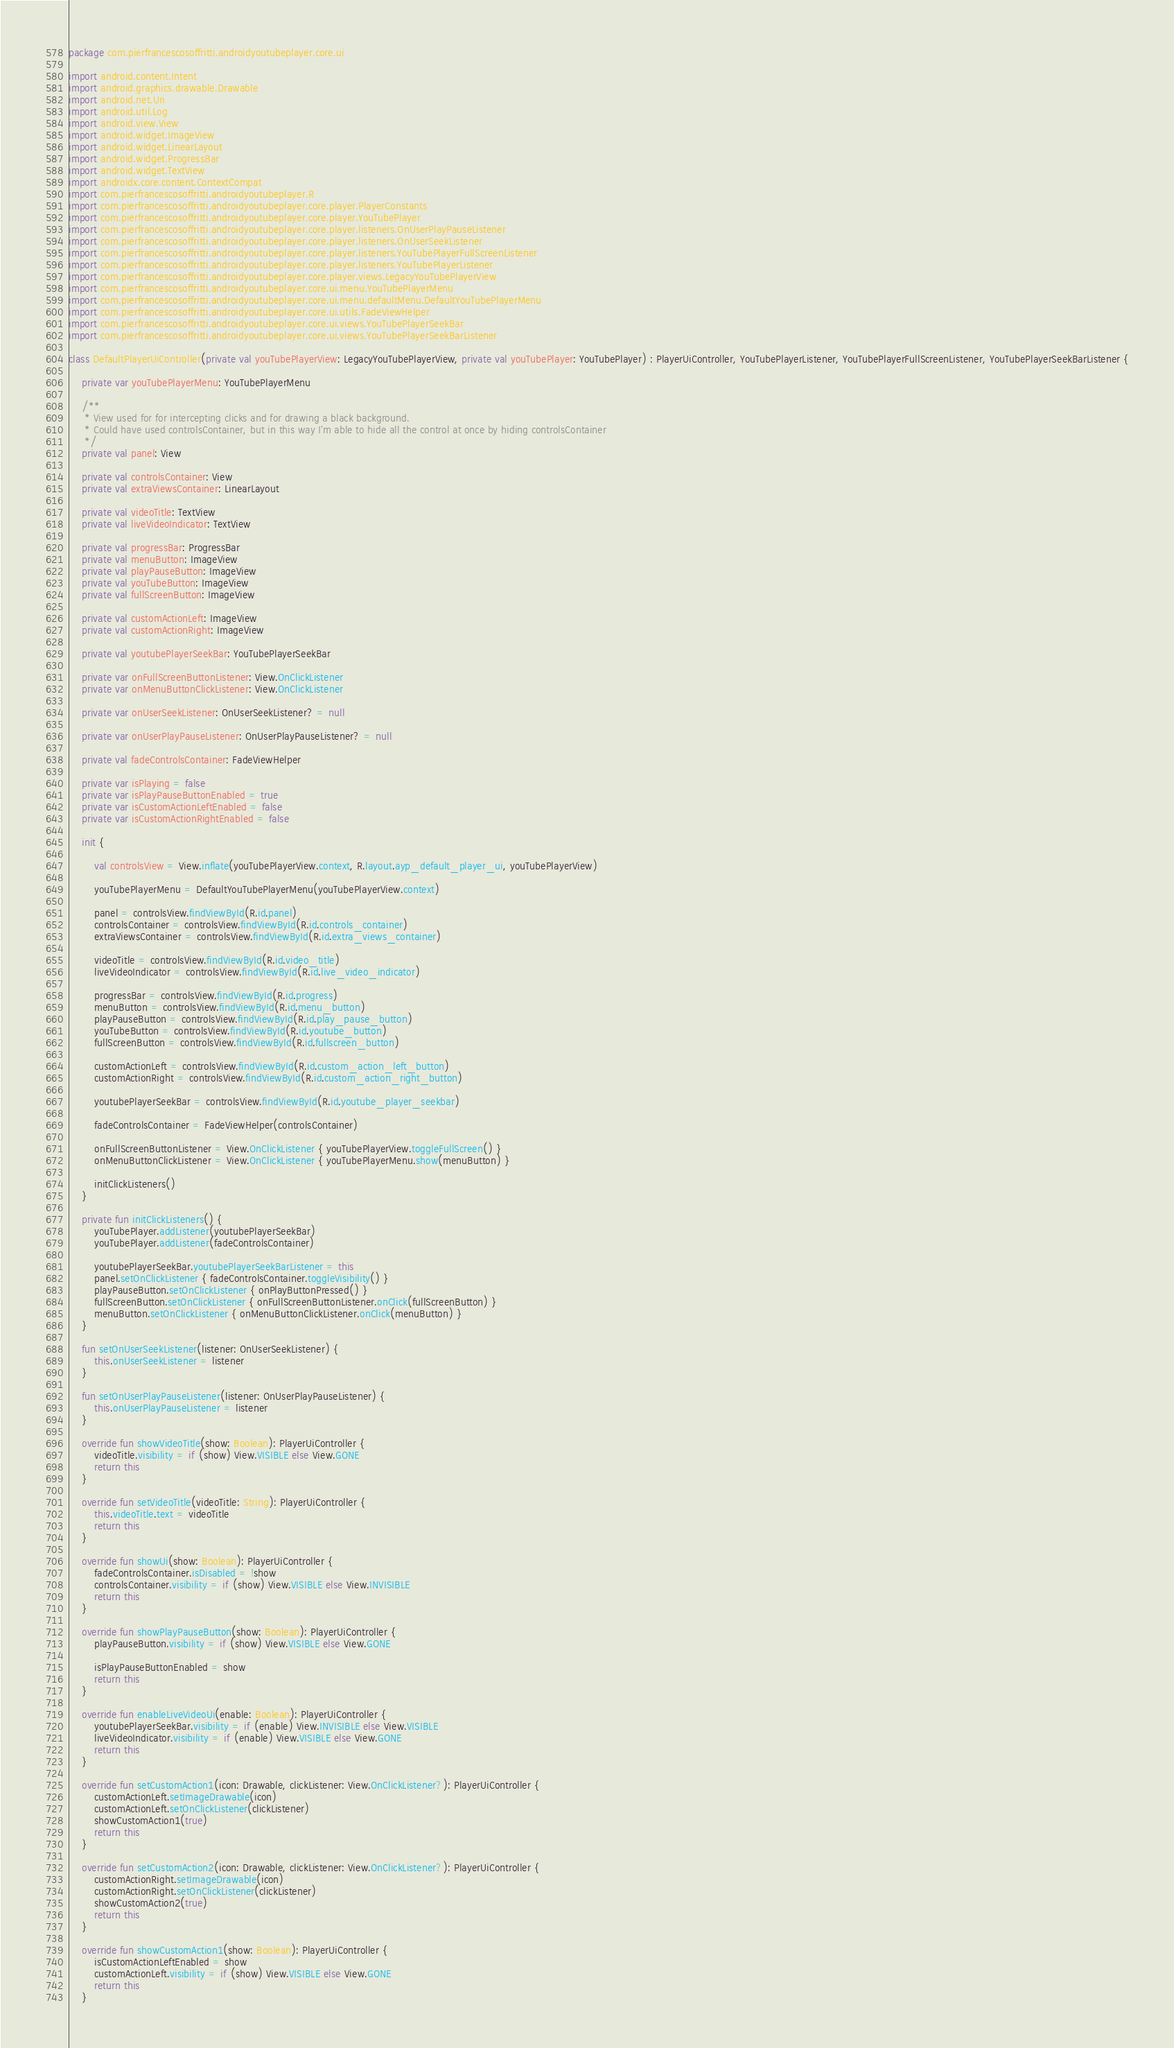Convert code to text. <code><loc_0><loc_0><loc_500><loc_500><_Kotlin_>package com.pierfrancescosoffritti.androidyoutubeplayer.core.ui

import android.content.Intent
import android.graphics.drawable.Drawable
import android.net.Uri
import android.util.Log
import android.view.View
import android.widget.ImageView
import android.widget.LinearLayout
import android.widget.ProgressBar
import android.widget.TextView
import androidx.core.content.ContextCompat
import com.pierfrancescosoffritti.androidyoutubeplayer.R
import com.pierfrancescosoffritti.androidyoutubeplayer.core.player.PlayerConstants
import com.pierfrancescosoffritti.androidyoutubeplayer.core.player.YouTubePlayer
import com.pierfrancescosoffritti.androidyoutubeplayer.core.player.listeners.OnUserPlayPauseListener
import com.pierfrancescosoffritti.androidyoutubeplayer.core.player.listeners.OnUserSeekListener
import com.pierfrancescosoffritti.androidyoutubeplayer.core.player.listeners.YouTubePlayerFullScreenListener
import com.pierfrancescosoffritti.androidyoutubeplayer.core.player.listeners.YouTubePlayerListener
import com.pierfrancescosoffritti.androidyoutubeplayer.core.player.views.LegacyYouTubePlayerView
import com.pierfrancescosoffritti.androidyoutubeplayer.core.ui.menu.YouTubePlayerMenu
import com.pierfrancescosoffritti.androidyoutubeplayer.core.ui.menu.defaultMenu.DefaultYouTubePlayerMenu
import com.pierfrancescosoffritti.androidyoutubeplayer.core.ui.utils.FadeViewHelper
import com.pierfrancescosoffritti.androidyoutubeplayer.core.ui.views.YouTubePlayerSeekBar
import com.pierfrancescosoffritti.androidyoutubeplayer.core.ui.views.YouTubePlayerSeekBarListener

class DefaultPlayerUiController(private val youTubePlayerView: LegacyYouTubePlayerView, private val youTubePlayer: YouTubePlayer) : PlayerUiController, YouTubePlayerListener, YouTubePlayerFullScreenListener, YouTubePlayerSeekBarListener {

    private var youTubePlayerMenu: YouTubePlayerMenu

    /**
     * View used for for intercepting clicks and for drawing a black background.
     * Could have used controlsContainer, but in this way I'm able to hide all the control at once by hiding controlsContainer
     */
    private val panel: View

    private val controlsContainer: View
    private val extraViewsContainer: LinearLayout

    private val videoTitle: TextView
    private val liveVideoIndicator: TextView

    private val progressBar: ProgressBar
    private val menuButton: ImageView
    private val playPauseButton: ImageView
    private val youTubeButton: ImageView
    private val fullScreenButton: ImageView

    private val customActionLeft: ImageView
    private val customActionRight: ImageView

    private val youtubePlayerSeekBar: YouTubePlayerSeekBar

    private var onFullScreenButtonListener: View.OnClickListener
    private var onMenuButtonClickListener: View.OnClickListener

    private var onUserSeekListener: OnUserSeekListener? = null

    private var onUserPlayPauseListener: OnUserPlayPauseListener? = null

    private val fadeControlsContainer: FadeViewHelper

    private var isPlaying = false
    private var isPlayPauseButtonEnabled = true
    private var isCustomActionLeftEnabled = false
    private var isCustomActionRightEnabled = false

    init {

        val controlsView = View.inflate(youTubePlayerView.context, R.layout.ayp_default_player_ui, youTubePlayerView)

        youTubePlayerMenu = DefaultYouTubePlayerMenu(youTubePlayerView.context)

        panel = controlsView.findViewById(R.id.panel)
        controlsContainer = controlsView.findViewById(R.id.controls_container)
        extraViewsContainer = controlsView.findViewById(R.id.extra_views_container)

        videoTitle = controlsView.findViewById(R.id.video_title)
        liveVideoIndicator = controlsView.findViewById(R.id.live_video_indicator)

        progressBar = controlsView.findViewById(R.id.progress)
        menuButton = controlsView.findViewById(R.id.menu_button)
        playPauseButton = controlsView.findViewById(R.id.play_pause_button)
        youTubeButton = controlsView.findViewById(R.id.youtube_button)
        fullScreenButton = controlsView.findViewById(R.id.fullscreen_button)

        customActionLeft = controlsView.findViewById(R.id.custom_action_left_button)
        customActionRight = controlsView.findViewById(R.id.custom_action_right_button)

        youtubePlayerSeekBar = controlsView.findViewById(R.id.youtube_player_seekbar)

        fadeControlsContainer = FadeViewHelper(controlsContainer)

        onFullScreenButtonListener = View.OnClickListener { youTubePlayerView.toggleFullScreen() }
        onMenuButtonClickListener = View.OnClickListener { youTubePlayerMenu.show(menuButton) }

        initClickListeners()
    }

    private fun initClickListeners() {
        youTubePlayer.addListener(youtubePlayerSeekBar)
        youTubePlayer.addListener(fadeControlsContainer)

        youtubePlayerSeekBar.youtubePlayerSeekBarListener = this
        panel.setOnClickListener { fadeControlsContainer.toggleVisibility() }
        playPauseButton.setOnClickListener { onPlayButtonPressed() }
        fullScreenButton.setOnClickListener { onFullScreenButtonListener.onClick(fullScreenButton) }
        menuButton.setOnClickListener { onMenuButtonClickListener.onClick(menuButton) }
    }

    fun setOnUserSeekListener(listener: OnUserSeekListener) {
        this.onUserSeekListener = listener
    }

    fun setOnUserPlayPauseListener(listener: OnUserPlayPauseListener) {
        this.onUserPlayPauseListener = listener
    }

    override fun showVideoTitle(show: Boolean): PlayerUiController {
        videoTitle.visibility = if (show) View.VISIBLE else View.GONE
        return this
    }

    override fun setVideoTitle(videoTitle: String): PlayerUiController {
        this.videoTitle.text = videoTitle
        return this
    }

    override fun showUi(show: Boolean): PlayerUiController {
        fadeControlsContainer.isDisabled = !show
        controlsContainer.visibility = if (show) View.VISIBLE else View.INVISIBLE
        return this
    }

    override fun showPlayPauseButton(show: Boolean): PlayerUiController {
        playPauseButton.visibility = if (show) View.VISIBLE else View.GONE

        isPlayPauseButtonEnabled = show
        return this
    }

    override fun enableLiveVideoUi(enable: Boolean): PlayerUiController {
        youtubePlayerSeekBar.visibility = if (enable) View.INVISIBLE else View.VISIBLE
        liveVideoIndicator.visibility = if (enable) View.VISIBLE else View.GONE
        return this
    }

    override fun setCustomAction1(icon: Drawable, clickListener: View.OnClickListener?): PlayerUiController {
        customActionLeft.setImageDrawable(icon)
        customActionLeft.setOnClickListener(clickListener)
        showCustomAction1(true)
        return this
    }

    override fun setCustomAction2(icon: Drawable, clickListener: View.OnClickListener?): PlayerUiController {
        customActionRight.setImageDrawable(icon)
        customActionRight.setOnClickListener(clickListener)
        showCustomAction2(true)
        return this
    }

    override fun showCustomAction1(show: Boolean): PlayerUiController {
        isCustomActionLeftEnabled = show
        customActionLeft.visibility = if (show) View.VISIBLE else View.GONE
        return this
    }
</code> 